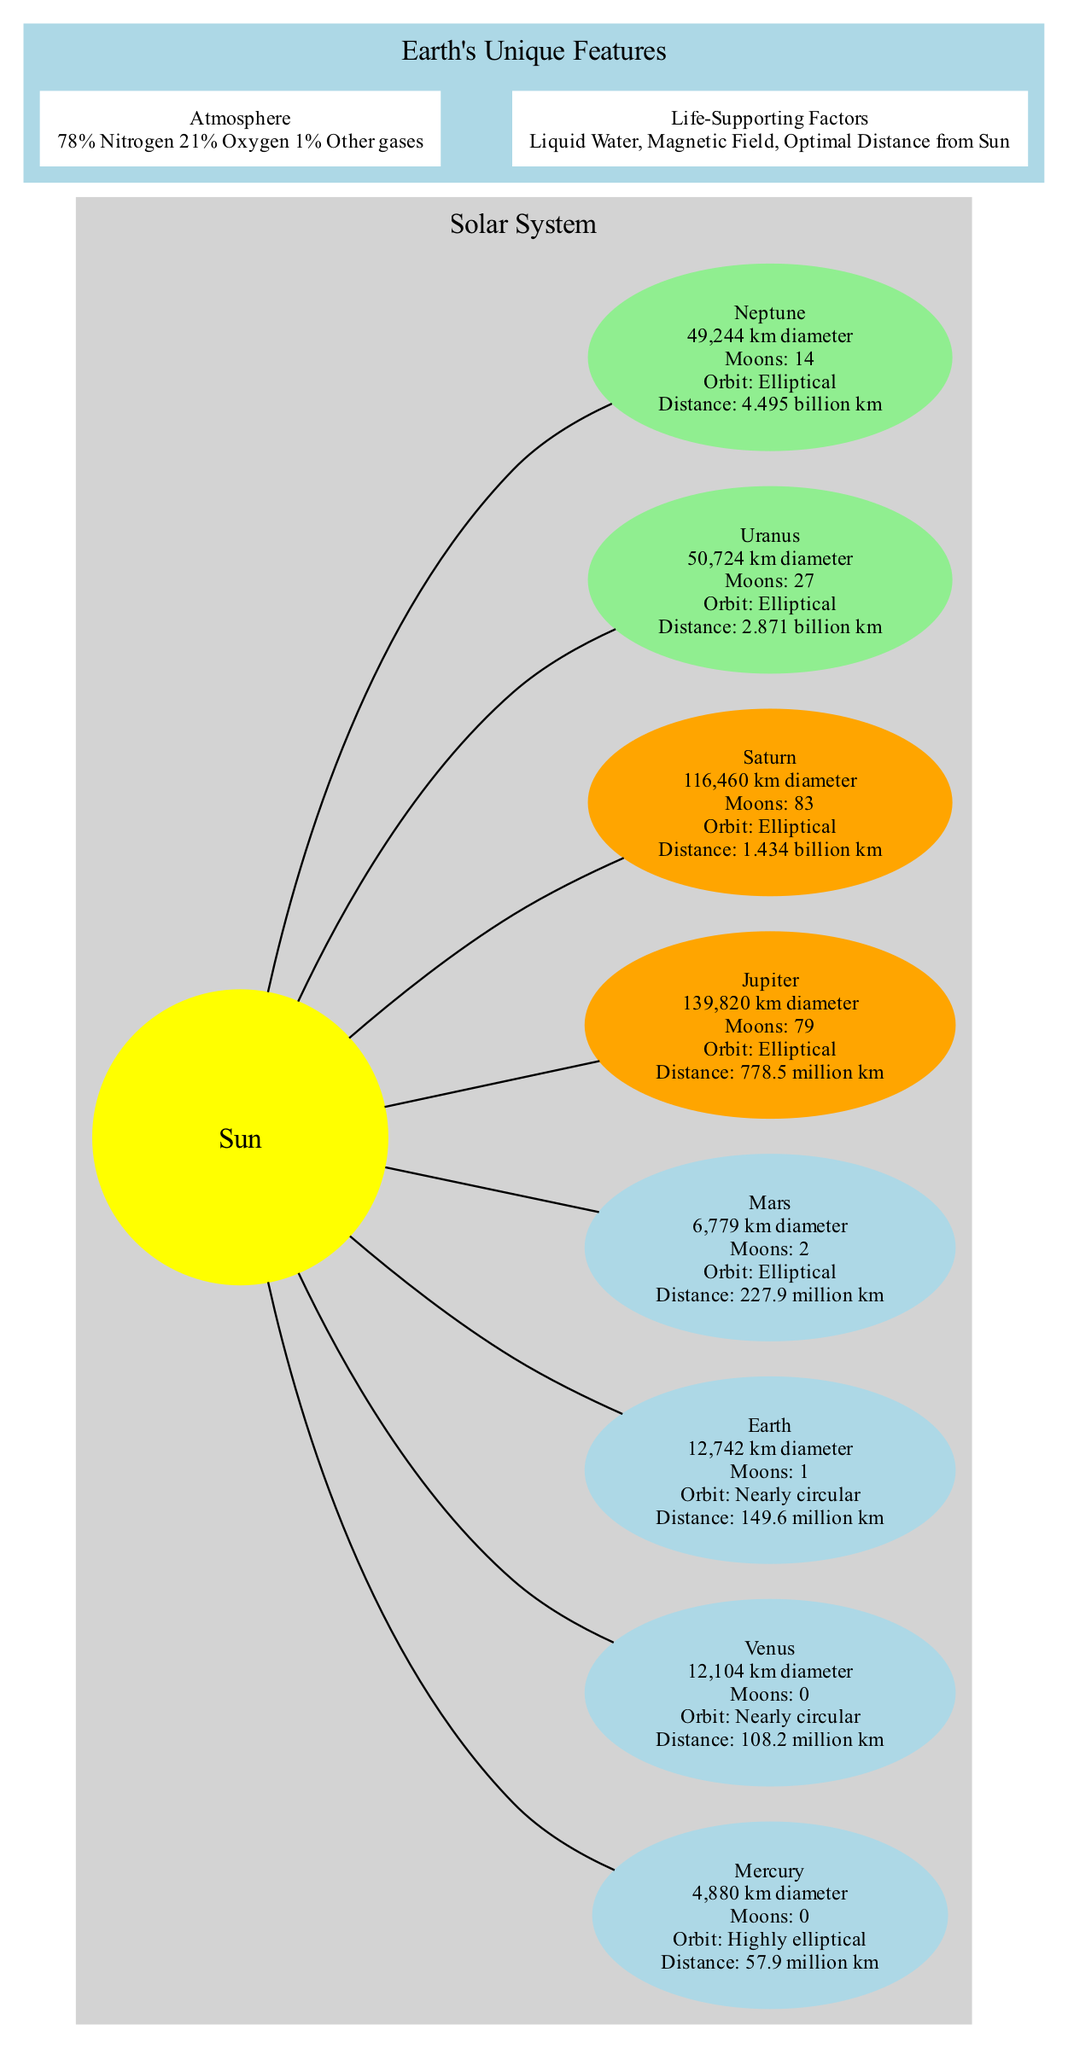What is the diameter of Jupiter? The diagram specifies the size of Jupiter as "139,820 km diameter," which is a direct label in the planet's node.
Answer: 139,820 km diameter How many moons does Earth have? The Earth node clearly states that it has "1" moon listed in its information.
Answer: 1 Which planet has the largest diameter? By comparing the sizes in the diagram, it is evident that Jupiter has the largest diameter at "139,820 km."
Answer: Jupiter What is the average distance of Mars from the Sun? The diagram indicates that Mars has an average distance from the Sun of "227.9 million km," which is specifically labeled in its node.
Answer: 227.9 million km Which planet's atmosphere contains 21% oxygen? The diagram details Earth's atmosphere and specifies that it is composed of "21% Oxygen," making it clear that Earth is the answer.
Answer: Earth How many planets have a nearly circular orbit? By inspecting the orbit characteristics in the diagram, it shows that both Earth and Venus have a "Nearly circular" orbit, thus accounting for 2 planets.
Answer: 2 What life-supporting factor is unique to Earth? The diagram lists "Liquid Water," "Magnetic Field," and "Optimal Distance from Sun" as life-supporting factors; any of these can be answered as unique to Earth.
Answer: Liquid Water Which planet is furthest from the Sun? The diagram shows the average distances from the Sun, and Neptune, which is 4.495 billion km away, is labeled as the planet furthest from the Sun.
Answer: Neptune How many moons does Saturn have? The information provided in the Saturn node specifies that it has "83" moons, which directly answers the question.
Answer: 83 